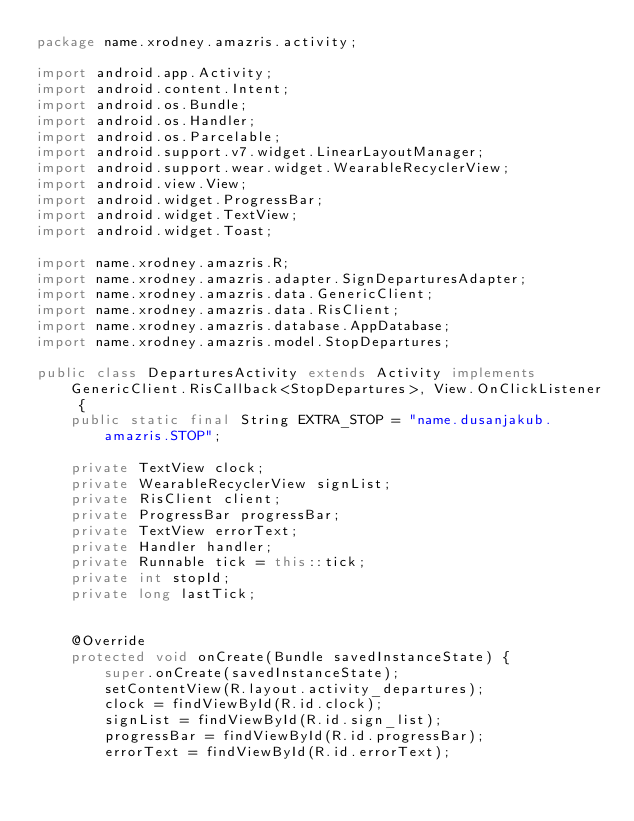Convert code to text. <code><loc_0><loc_0><loc_500><loc_500><_Java_>package name.xrodney.amazris.activity;

import android.app.Activity;
import android.content.Intent;
import android.os.Bundle;
import android.os.Handler;
import android.os.Parcelable;
import android.support.v7.widget.LinearLayoutManager;
import android.support.wear.widget.WearableRecyclerView;
import android.view.View;
import android.widget.ProgressBar;
import android.widget.TextView;
import android.widget.Toast;

import name.xrodney.amazris.R;
import name.xrodney.amazris.adapter.SignDeparturesAdapter;
import name.xrodney.amazris.data.GenericClient;
import name.xrodney.amazris.data.RisClient;
import name.xrodney.amazris.database.AppDatabase;
import name.xrodney.amazris.model.StopDepartures;

public class DeparturesActivity extends Activity implements GenericClient.RisCallback<StopDepartures>, View.OnClickListener {
    public static final String EXTRA_STOP = "name.dusanjakub.amazris.STOP";

    private TextView clock;
    private WearableRecyclerView signList;
    private RisClient client;
    private ProgressBar progressBar;
    private TextView errorText;
    private Handler handler;
    private Runnable tick = this::tick;
    private int stopId;
    private long lastTick;


    @Override
    protected void onCreate(Bundle savedInstanceState) {
        super.onCreate(savedInstanceState);
        setContentView(R.layout.activity_departures);
        clock = findViewById(R.id.clock);
        signList = findViewById(R.id.sign_list);
        progressBar = findViewById(R.id.progressBar);
        errorText = findViewById(R.id.errorText);</code> 